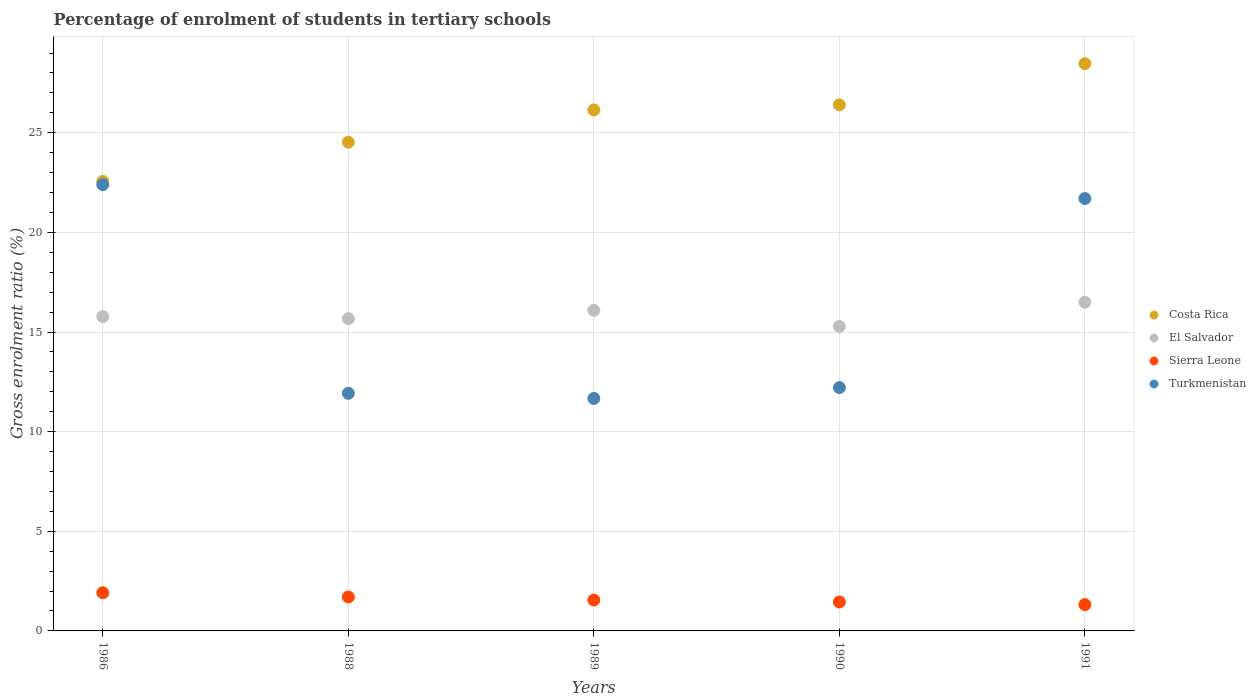What is the percentage of students enrolled in tertiary schools in Costa Rica in 1990?
Provide a succinct answer. 26.4. Across all years, what is the maximum percentage of students enrolled in tertiary schools in Turkmenistan?
Keep it short and to the point. 22.4. Across all years, what is the minimum percentage of students enrolled in tertiary schools in Costa Rica?
Provide a short and direct response. 22.56. What is the total percentage of students enrolled in tertiary schools in El Salvador in the graph?
Your answer should be compact. 79.31. What is the difference between the percentage of students enrolled in tertiary schools in Turkmenistan in 1986 and that in 1989?
Your answer should be very brief. 10.73. What is the difference between the percentage of students enrolled in tertiary schools in El Salvador in 1988 and the percentage of students enrolled in tertiary schools in Turkmenistan in 1989?
Your answer should be compact. 4.01. What is the average percentage of students enrolled in tertiary schools in Turkmenistan per year?
Offer a terse response. 15.98. In the year 1990, what is the difference between the percentage of students enrolled in tertiary schools in Costa Rica and percentage of students enrolled in tertiary schools in El Salvador?
Offer a very short reply. 11.12. What is the ratio of the percentage of students enrolled in tertiary schools in Turkmenistan in 1986 to that in 1991?
Offer a terse response. 1.03. Is the percentage of students enrolled in tertiary schools in Costa Rica in 1986 less than that in 1990?
Offer a very short reply. Yes. Is the difference between the percentage of students enrolled in tertiary schools in Costa Rica in 1988 and 1989 greater than the difference between the percentage of students enrolled in tertiary schools in El Salvador in 1988 and 1989?
Keep it short and to the point. No. What is the difference between the highest and the second highest percentage of students enrolled in tertiary schools in Costa Rica?
Your answer should be very brief. 2.07. What is the difference between the highest and the lowest percentage of students enrolled in tertiary schools in El Salvador?
Make the answer very short. 1.22. In how many years, is the percentage of students enrolled in tertiary schools in Sierra Leone greater than the average percentage of students enrolled in tertiary schools in Sierra Leone taken over all years?
Offer a terse response. 2. Is it the case that in every year, the sum of the percentage of students enrolled in tertiary schools in Sierra Leone and percentage of students enrolled in tertiary schools in El Salvador  is greater than the percentage of students enrolled in tertiary schools in Turkmenistan?
Offer a very short reply. No. Is the percentage of students enrolled in tertiary schools in Sierra Leone strictly less than the percentage of students enrolled in tertiary schools in Turkmenistan over the years?
Your response must be concise. Yes. How many dotlines are there?
Ensure brevity in your answer.  4. How many years are there in the graph?
Ensure brevity in your answer.  5. Are the values on the major ticks of Y-axis written in scientific E-notation?
Make the answer very short. No. Does the graph contain grids?
Make the answer very short. Yes. Where does the legend appear in the graph?
Offer a terse response. Center right. How many legend labels are there?
Ensure brevity in your answer.  4. How are the legend labels stacked?
Your answer should be very brief. Vertical. What is the title of the graph?
Make the answer very short. Percentage of enrolment of students in tertiary schools. What is the label or title of the X-axis?
Ensure brevity in your answer.  Years. What is the label or title of the Y-axis?
Your answer should be compact. Gross enrolment ratio (%). What is the Gross enrolment ratio (%) in Costa Rica in 1986?
Your answer should be very brief. 22.56. What is the Gross enrolment ratio (%) in El Salvador in 1986?
Give a very brief answer. 15.77. What is the Gross enrolment ratio (%) in Sierra Leone in 1986?
Make the answer very short. 1.92. What is the Gross enrolment ratio (%) of Turkmenistan in 1986?
Your answer should be compact. 22.4. What is the Gross enrolment ratio (%) of Costa Rica in 1988?
Keep it short and to the point. 24.52. What is the Gross enrolment ratio (%) in El Salvador in 1988?
Ensure brevity in your answer.  15.67. What is the Gross enrolment ratio (%) in Sierra Leone in 1988?
Offer a terse response. 1.7. What is the Gross enrolment ratio (%) of Turkmenistan in 1988?
Offer a terse response. 11.92. What is the Gross enrolment ratio (%) of Costa Rica in 1989?
Keep it short and to the point. 26.14. What is the Gross enrolment ratio (%) of El Salvador in 1989?
Make the answer very short. 16.09. What is the Gross enrolment ratio (%) of Sierra Leone in 1989?
Your response must be concise. 1.55. What is the Gross enrolment ratio (%) of Turkmenistan in 1989?
Offer a terse response. 11.66. What is the Gross enrolment ratio (%) of Costa Rica in 1990?
Make the answer very short. 26.4. What is the Gross enrolment ratio (%) of El Salvador in 1990?
Offer a terse response. 15.28. What is the Gross enrolment ratio (%) in Sierra Leone in 1990?
Your answer should be very brief. 1.45. What is the Gross enrolment ratio (%) in Turkmenistan in 1990?
Provide a short and direct response. 12.21. What is the Gross enrolment ratio (%) of Costa Rica in 1991?
Make the answer very short. 28.47. What is the Gross enrolment ratio (%) of El Salvador in 1991?
Provide a short and direct response. 16.49. What is the Gross enrolment ratio (%) in Sierra Leone in 1991?
Make the answer very short. 1.32. What is the Gross enrolment ratio (%) in Turkmenistan in 1991?
Provide a succinct answer. 21.7. Across all years, what is the maximum Gross enrolment ratio (%) in Costa Rica?
Offer a terse response. 28.47. Across all years, what is the maximum Gross enrolment ratio (%) in El Salvador?
Keep it short and to the point. 16.49. Across all years, what is the maximum Gross enrolment ratio (%) of Sierra Leone?
Provide a short and direct response. 1.92. Across all years, what is the maximum Gross enrolment ratio (%) in Turkmenistan?
Provide a succinct answer. 22.4. Across all years, what is the minimum Gross enrolment ratio (%) in Costa Rica?
Provide a short and direct response. 22.56. Across all years, what is the minimum Gross enrolment ratio (%) of El Salvador?
Provide a succinct answer. 15.28. Across all years, what is the minimum Gross enrolment ratio (%) in Sierra Leone?
Offer a very short reply. 1.32. Across all years, what is the minimum Gross enrolment ratio (%) of Turkmenistan?
Your response must be concise. 11.66. What is the total Gross enrolment ratio (%) in Costa Rica in the graph?
Offer a terse response. 128.09. What is the total Gross enrolment ratio (%) in El Salvador in the graph?
Your response must be concise. 79.31. What is the total Gross enrolment ratio (%) in Sierra Leone in the graph?
Offer a terse response. 7.94. What is the total Gross enrolment ratio (%) in Turkmenistan in the graph?
Your answer should be very brief. 79.89. What is the difference between the Gross enrolment ratio (%) of Costa Rica in 1986 and that in 1988?
Your answer should be compact. -1.96. What is the difference between the Gross enrolment ratio (%) of El Salvador in 1986 and that in 1988?
Keep it short and to the point. 0.1. What is the difference between the Gross enrolment ratio (%) in Sierra Leone in 1986 and that in 1988?
Your answer should be very brief. 0.21. What is the difference between the Gross enrolment ratio (%) of Turkmenistan in 1986 and that in 1988?
Your answer should be very brief. 10.47. What is the difference between the Gross enrolment ratio (%) in Costa Rica in 1986 and that in 1989?
Make the answer very short. -3.58. What is the difference between the Gross enrolment ratio (%) of El Salvador in 1986 and that in 1989?
Offer a terse response. -0.32. What is the difference between the Gross enrolment ratio (%) in Sierra Leone in 1986 and that in 1989?
Offer a very short reply. 0.37. What is the difference between the Gross enrolment ratio (%) in Turkmenistan in 1986 and that in 1989?
Give a very brief answer. 10.73. What is the difference between the Gross enrolment ratio (%) in Costa Rica in 1986 and that in 1990?
Make the answer very short. -3.84. What is the difference between the Gross enrolment ratio (%) of El Salvador in 1986 and that in 1990?
Provide a succinct answer. 0.49. What is the difference between the Gross enrolment ratio (%) in Sierra Leone in 1986 and that in 1990?
Offer a terse response. 0.46. What is the difference between the Gross enrolment ratio (%) of Turkmenistan in 1986 and that in 1990?
Ensure brevity in your answer.  10.19. What is the difference between the Gross enrolment ratio (%) of Costa Rica in 1986 and that in 1991?
Make the answer very short. -5.91. What is the difference between the Gross enrolment ratio (%) in El Salvador in 1986 and that in 1991?
Offer a very short reply. -0.72. What is the difference between the Gross enrolment ratio (%) of Sierra Leone in 1986 and that in 1991?
Your answer should be compact. 0.6. What is the difference between the Gross enrolment ratio (%) of Turkmenistan in 1986 and that in 1991?
Make the answer very short. 0.7. What is the difference between the Gross enrolment ratio (%) of Costa Rica in 1988 and that in 1989?
Keep it short and to the point. -1.62. What is the difference between the Gross enrolment ratio (%) in El Salvador in 1988 and that in 1989?
Offer a very short reply. -0.42. What is the difference between the Gross enrolment ratio (%) of Sierra Leone in 1988 and that in 1989?
Offer a terse response. 0.15. What is the difference between the Gross enrolment ratio (%) of Turkmenistan in 1988 and that in 1989?
Your response must be concise. 0.26. What is the difference between the Gross enrolment ratio (%) in Costa Rica in 1988 and that in 1990?
Ensure brevity in your answer.  -1.88. What is the difference between the Gross enrolment ratio (%) of El Salvador in 1988 and that in 1990?
Ensure brevity in your answer.  0.39. What is the difference between the Gross enrolment ratio (%) of Sierra Leone in 1988 and that in 1990?
Your answer should be very brief. 0.25. What is the difference between the Gross enrolment ratio (%) of Turkmenistan in 1988 and that in 1990?
Provide a succinct answer. -0.29. What is the difference between the Gross enrolment ratio (%) in Costa Rica in 1988 and that in 1991?
Provide a succinct answer. -3.94. What is the difference between the Gross enrolment ratio (%) of El Salvador in 1988 and that in 1991?
Offer a terse response. -0.82. What is the difference between the Gross enrolment ratio (%) of Sierra Leone in 1988 and that in 1991?
Give a very brief answer. 0.38. What is the difference between the Gross enrolment ratio (%) in Turkmenistan in 1988 and that in 1991?
Ensure brevity in your answer.  -9.77. What is the difference between the Gross enrolment ratio (%) of Costa Rica in 1989 and that in 1990?
Your response must be concise. -0.26. What is the difference between the Gross enrolment ratio (%) of El Salvador in 1989 and that in 1990?
Offer a very short reply. 0.81. What is the difference between the Gross enrolment ratio (%) in Sierra Leone in 1989 and that in 1990?
Your answer should be compact. 0.1. What is the difference between the Gross enrolment ratio (%) of Turkmenistan in 1989 and that in 1990?
Make the answer very short. -0.55. What is the difference between the Gross enrolment ratio (%) in Costa Rica in 1989 and that in 1991?
Your answer should be compact. -2.32. What is the difference between the Gross enrolment ratio (%) of El Salvador in 1989 and that in 1991?
Give a very brief answer. -0.4. What is the difference between the Gross enrolment ratio (%) of Sierra Leone in 1989 and that in 1991?
Ensure brevity in your answer.  0.23. What is the difference between the Gross enrolment ratio (%) of Turkmenistan in 1989 and that in 1991?
Provide a succinct answer. -10.03. What is the difference between the Gross enrolment ratio (%) of Costa Rica in 1990 and that in 1991?
Ensure brevity in your answer.  -2.07. What is the difference between the Gross enrolment ratio (%) in El Salvador in 1990 and that in 1991?
Give a very brief answer. -1.22. What is the difference between the Gross enrolment ratio (%) in Sierra Leone in 1990 and that in 1991?
Give a very brief answer. 0.13. What is the difference between the Gross enrolment ratio (%) of Turkmenistan in 1990 and that in 1991?
Offer a very short reply. -9.48. What is the difference between the Gross enrolment ratio (%) of Costa Rica in 1986 and the Gross enrolment ratio (%) of El Salvador in 1988?
Offer a very short reply. 6.89. What is the difference between the Gross enrolment ratio (%) of Costa Rica in 1986 and the Gross enrolment ratio (%) of Sierra Leone in 1988?
Ensure brevity in your answer.  20.85. What is the difference between the Gross enrolment ratio (%) of Costa Rica in 1986 and the Gross enrolment ratio (%) of Turkmenistan in 1988?
Give a very brief answer. 10.63. What is the difference between the Gross enrolment ratio (%) in El Salvador in 1986 and the Gross enrolment ratio (%) in Sierra Leone in 1988?
Give a very brief answer. 14.07. What is the difference between the Gross enrolment ratio (%) in El Salvador in 1986 and the Gross enrolment ratio (%) in Turkmenistan in 1988?
Keep it short and to the point. 3.85. What is the difference between the Gross enrolment ratio (%) of Sierra Leone in 1986 and the Gross enrolment ratio (%) of Turkmenistan in 1988?
Offer a very short reply. -10.01. What is the difference between the Gross enrolment ratio (%) of Costa Rica in 1986 and the Gross enrolment ratio (%) of El Salvador in 1989?
Offer a very short reply. 6.47. What is the difference between the Gross enrolment ratio (%) of Costa Rica in 1986 and the Gross enrolment ratio (%) of Sierra Leone in 1989?
Your answer should be compact. 21.01. What is the difference between the Gross enrolment ratio (%) in Costa Rica in 1986 and the Gross enrolment ratio (%) in Turkmenistan in 1989?
Provide a short and direct response. 10.89. What is the difference between the Gross enrolment ratio (%) in El Salvador in 1986 and the Gross enrolment ratio (%) in Sierra Leone in 1989?
Ensure brevity in your answer.  14.22. What is the difference between the Gross enrolment ratio (%) in El Salvador in 1986 and the Gross enrolment ratio (%) in Turkmenistan in 1989?
Ensure brevity in your answer.  4.11. What is the difference between the Gross enrolment ratio (%) in Sierra Leone in 1986 and the Gross enrolment ratio (%) in Turkmenistan in 1989?
Give a very brief answer. -9.75. What is the difference between the Gross enrolment ratio (%) in Costa Rica in 1986 and the Gross enrolment ratio (%) in El Salvador in 1990?
Provide a short and direct response. 7.28. What is the difference between the Gross enrolment ratio (%) of Costa Rica in 1986 and the Gross enrolment ratio (%) of Sierra Leone in 1990?
Give a very brief answer. 21.11. What is the difference between the Gross enrolment ratio (%) of Costa Rica in 1986 and the Gross enrolment ratio (%) of Turkmenistan in 1990?
Keep it short and to the point. 10.35. What is the difference between the Gross enrolment ratio (%) of El Salvador in 1986 and the Gross enrolment ratio (%) of Sierra Leone in 1990?
Offer a very short reply. 14.32. What is the difference between the Gross enrolment ratio (%) in El Salvador in 1986 and the Gross enrolment ratio (%) in Turkmenistan in 1990?
Your answer should be compact. 3.56. What is the difference between the Gross enrolment ratio (%) of Sierra Leone in 1986 and the Gross enrolment ratio (%) of Turkmenistan in 1990?
Keep it short and to the point. -10.3. What is the difference between the Gross enrolment ratio (%) in Costa Rica in 1986 and the Gross enrolment ratio (%) in El Salvador in 1991?
Provide a short and direct response. 6.06. What is the difference between the Gross enrolment ratio (%) of Costa Rica in 1986 and the Gross enrolment ratio (%) of Sierra Leone in 1991?
Your response must be concise. 21.24. What is the difference between the Gross enrolment ratio (%) in Costa Rica in 1986 and the Gross enrolment ratio (%) in Turkmenistan in 1991?
Give a very brief answer. 0.86. What is the difference between the Gross enrolment ratio (%) in El Salvador in 1986 and the Gross enrolment ratio (%) in Sierra Leone in 1991?
Keep it short and to the point. 14.45. What is the difference between the Gross enrolment ratio (%) of El Salvador in 1986 and the Gross enrolment ratio (%) of Turkmenistan in 1991?
Give a very brief answer. -5.93. What is the difference between the Gross enrolment ratio (%) of Sierra Leone in 1986 and the Gross enrolment ratio (%) of Turkmenistan in 1991?
Your answer should be compact. -19.78. What is the difference between the Gross enrolment ratio (%) of Costa Rica in 1988 and the Gross enrolment ratio (%) of El Salvador in 1989?
Offer a very short reply. 8.43. What is the difference between the Gross enrolment ratio (%) of Costa Rica in 1988 and the Gross enrolment ratio (%) of Sierra Leone in 1989?
Offer a terse response. 22.97. What is the difference between the Gross enrolment ratio (%) of Costa Rica in 1988 and the Gross enrolment ratio (%) of Turkmenistan in 1989?
Give a very brief answer. 12.86. What is the difference between the Gross enrolment ratio (%) in El Salvador in 1988 and the Gross enrolment ratio (%) in Sierra Leone in 1989?
Offer a terse response. 14.12. What is the difference between the Gross enrolment ratio (%) in El Salvador in 1988 and the Gross enrolment ratio (%) in Turkmenistan in 1989?
Offer a very short reply. 4.01. What is the difference between the Gross enrolment ratio (%) of Sierra Leone in 1988 and the Gross enrolment ratio (%) of Turkmenistan in 1989?
Keep it short and to the point. -9.96. What is the difference between the Gross enrolment ratio (%) of Costa Rica in 1988 and the Gross enrolment ratio (%) of El Salvador in 1990?
Give a very brief answer. 9.25. What is the difference between the Gross enrolment ratio (%) in Costa Rica in 1988 and the Gross enrolment ratio (%) in Sierra Leone in 1990?
Offer a terse response. 23.07. What is the difference between the Gross enrolment ratio (%) of Costa Rica in 1988 and the Gross enrolment ratio (%) of Turkmenistan in 1990?
Make the answer very short. 12.31. What is the difference between the Gross enrolment ratio (%) in El Salvador in 1988 and the Gross enrolment ratio (%) in Sierra Leone in 1990?
Keep it short and to the point. 14.22. What is the difference between the Gross enrolment ratio (%) in El Salvador in 1988 and the Gross enrolment ratio (%) in Turkmenistan in 1990?
Your answer should be compact. 3.46. What is the difference between the Gross enrolment ratio (%) of Sierra Leone in 1988 and the Gross enrolment ratio (%) of Turkmenistan in 1990?
Provide a short and direct response. -10.51. What is the difference between the Gross enrolment ratio (%) of Costa Rica in 1988 and the Gross enrolment ratio (%) of El Salvador in 1991?
Give a very brief answer. 8.03. What is the difference between the Gross enrolment ratio (%) in Costa Rica in 1988 and the Gross enrolment ratio (%) in Sierra Leone in 1991?
Your response must be concise. 23.2. What is the difference between the Gross enrolment ratio (%) of Costa Rica in 1988 and the Gross enrolment ratio (%) of Turkmenistan in 1991?
Give a very brief answer. 2.83. What is the difference between the Gross enrolment ratio (%) in El Salvador in 1988 and the Gross enrolment ratio (%) in Sierra Leone in 1991?
Make the answer very short. 14.35. What is the difference between the Gross enrolment ratio (%) of El Salvador in 1988 and the Gross enrolment ratio (%) of Turkmenistan in 1991?
Your answer should be very brief. -6.03. What is the difference between the Gross enrolment ratio (%) in Sierra Leone in 1988 and the Gross enrolment ratio (%) in Turkmenistan in 1991?
Offer a very short reply. -19.99. What is the difference between the Gross enrolment ratio (%) in Costa Rica in 1989 and the Gross enrolment ratio (%) in El Salvador in 1990?
Your answer should be compact. 10.86. What is the difference between the Gross enrolment ratio (%) of Costa Rica in 1989 and the Gross enrolment ratio (%) of Sierra Leone in 1990?
Give a very brief answer. 24.69. What is the difference between the Gross enrolment ratio (%) of Costa Rica in 1989 and the Gross enrolment ratio (%) of Turkmenistan in 1990?
Ensure brevity in your answer.  13.93. What is the difference between the Gross enrolment ratio (%) in El Salvador in 1989 and the Gross enrolment ratio (%) in Sierra Leone in 1990?
Provide a short and direct response. 14.64. What is the difference between the Gross enrolment ratio (%) of El Salvador in 1989 and the Gross enrolment ratio (%) of Turkmenistan in 1990?
Provide a short and direct response. 3.88. What is the difference between the Gross enrolment ratio (%) of Sierra Leone in 1989 and the Gross enrolment ratio (%) of Turkmenistan in 1990?
Provide a short and direct response. -10.66. What is the difference between the Gross enrolment ratio (%) in Costa Rica in 1989 and the Gross enrolment ratio (%) in El Salvador in 1991?
Your response must be concise. 9.65. What is the difference between the Gross enrolment ratio (%) of Costa Rica in 1989 and the Gross enrolment ratio (%) of Sierra Leone in 1991?
Provide a succinct answer. 24.82. What is the difference between the Gross enrolment ratio (%) in Costa Rica in 1989 and the Gross enrolment ratio (%) in Turkmenistan in 1991?
Make the answer very short. 4.45. What is the difference between the Gross enrolment ratio (%) of El Salvador in 1989 and the Gross enrolment ratio (%) of Sierra Leone in 1991?
Ensure brevity in your answer.  14.77. What is the difference between the Gross enrolment ratio (%) of El Salvador in 1989 and the Gross enrolment ratio (%) of Turkmenistan in 1991?
Offer a terse response. -5.6. What is the difference between the Gross enrolment ratio (%) in Sierra Leone in 1989 and the Gross enrolment ratio (%) in Turkmenistan in 1991?
Make the answer very short. -20.15. What is the difference between the Gross enrolment ratio (%) of Costa Rica in 1990 and the Gross enrolment ratio (%) of El Salvador in 1991?
Provide a succinct answer. 9.9. What is the difference between the Gross enrolment ratio (%) of Costa Rica in 1990 and the Gross enrolment ratio (%) of Sierra Leone in 1991?
Your answer should be compact. 25.08. What is the difference between the Gross enrolment ratio (%) in Costa Rica in 1990 and the Gross enrolment ratio (%) in Turkmenistan in 1991?
Your response must be concise. 4.7. What is the difference between the Gross enrolment ratio (%) of El Salvador in 1990 and the Gross enrolment ratio (%) of Sierra Leone in 1991?
Provide a succinct answer. 13.96. What is the difference between the Gross enrolment ratio (%) of El Salvador in 1990 and the Gross enrolment ratio (%) of Turkmenistan in 1991?
Give a very brief answer. -6.42. What is the difference between the Gross enrolment ratio (%) of Sierra Leone in 1990 and the Gross enrolment ratio (%) of Turkmenistan in 1991?
Offer a terse response. -20.24. What is the average Gross enrolment ratio (%) in Costa Rica per year?
Your answer should be compact. 25.62. What is the average Gross enrolment ratio (%) in El Salvador per year?
Make the answer very short. 15.86. What is the average Gross enrolment ratio (%) of Sierra Leone per year?
Provide a succinct answer. 1.59. What is the average Gross enrolment ratio (%) of Turkmenistan per year?
Offer a very short reply. 15.98. In the year 1986, what is the difference between the Gross enrolment ratio (%) of Costa Rica and Gross enrolment ratio (%) of El Salvador?
Ensure brevity in your answer.  6.79. In the year 1986, what is the difference between the Gross enrolment ratio (%) of Costa Rica and Gross enrolment ratio (%) of Sierra Leone?
Make the answer very short. 20.64. In the year 1986, what is the difference between the Gross enrolment ratio (%) in Costa Rica and Gross enrolment ratio (%) in Turkmenistan?
Your response must be concise. 0.16. In the year 1986, what is the difference between the Gross enrolment ratio (%) in El Salvador and Gross enrolment ratio (%) in Sierra Leone?
Your answer should be compact. 13.86. In the year 1986, what is the difference between the Gross enrolment ratio (%) in El Salvador and Gross enrolment ratio (%) in Turkmenistan?
Make the answer very short. -6.63. In the year 1986, what is the difference between the Gross enrolment ratio (%) in Sierra Leone and Gross enrolment ratio (%) in Turkmenistan?
Give a very brief answer. -20.48. In the year 1988, what is the difference between the Gross enrolment ratio (%) in Costa Rica and Gross enrolment ratio (%) in El Salvador?
Give a very brief answer. 8.85. In the year 1988, what is the difference between the Gross enrolment ratio (%) of Costa Rica and Gross enrolment ratio (%) of Sierra Leone?
Your answer should be very brief. 22.82. In the year 1988, what is the difference between the Gross enrolment ratio (%) in Costa Rica and Gross enrolment ratio (%) in Turkmenistan?
Make the answer very short. 12.6. In the year 1988, what is the difference between the Gross enrolment ratio (%) of El Salvador and Gross enrolment ratio (%) of Sierra Leone?
Your response must be concise. 13.97. In the year 1988, what is the difference between the Gross enrolment ratio (%) in El Salvador and Gross enrolment ratio (%) in Turkmenistan?
Make the answer very short. 3.75. In the year 1988, what is the difference between the Gross enrolment ratio (%) in Sierra Leone and Gross enrolment ratio (%) in Turkmenistan?
Your response must be concise. -10.22. In the year 1989, what is the difference between the Gross enrolment ratio (%) in Costa Rica and Gross enrolment ratio (%) in El Salvador?
Your response must be concise. 10.05. In the year 1989, what is the difference between the Gross enrolment ratio (%) in Costa Rica and Gross enrolment ratio (%) in Sierra Leone?
Give a very brief answer. 24.59. In the year 1989, what is the difference between the Gross enrolment ratio (%) of Costa Rica and Gross enrolment ratio (%) of Turkmenistan?
Make the answer very short. 14.48. In the year 1989, what is the difference between the Gross enrolment ratio (%) in El Salvador and Gross enrolment ratio (%) in Sierra Leone?
Provide a short and direct response. 14.54. In the year 1989, what is the difference between the Gross enrolment ratio (%) in El Salvador and Gross enrolment ratio (%) in Turkmenistan?
Your answer should be compact. 4.43. In the year 1989, what is the difference between the Gross enrolment ratio (%) in Sierra Leone and Gross enrolment ratio (%) in Turkmenistan?
Your answer should be compact. -10.12. In the year 1990, what is the difference between the Gross enrolment ratio (%) of Costa Rica and Gross enrolment ratio (%) of El Salvador?
Your answer should be compact. 11.12. In the year 1990, what is the difference between the Gross enrolment ratio (%) of Costa Rica and Gross enrolment ratio (%) of Sierra Leone?
Provide a short and direct response. 24.95. In the year 1990, what is the difference between the Gross enrolment ratio (%) of Costa Rica and Gross enrolment ratio (%) of Turkmenistan?
Give a very brief answer. 14.19. In the year 1990, what is the difference between the Gross enrolment ratio (%) of El Salvador and Gross enrolment ratio (%) of Sierra Leone?
Offer a terse response. 13.83. In the year 1990, what is the difference between the Gross enrolment ratio (%) of El Salvador and Gross enrolment ratio (%) of Turkmenistan?
Your response must be concise. 3.07. In the year 1990, what is the difference between the Gross enrolment ratio (%) of Sierra Leone and Gross enrolment ratio (%) of Turkmenistan?
Your answer should be compact. -10.76. In the year 1991, what is the difference between the Gross enrolment ratio (%) in Costa Rica and Gross enrolment ratio (%) in El Salvador?
Give a very brief answer. 11.97. In the year 1991, what is the difference between the Gross enrolment ratio (%) of Costa Rica and Gross enrolment ratio (%) of Sierra Leone?
Provide a short and direct response. 27.15. In the year 1991, what is the difference between the Gross enrolment ratio (%) of Costa Rica and Gross enrolment ratio (%) of Turkmenistan?
Keep it short and to the point. 6.77. In the year 1991, what is the difference between the Gross enrolment ratio (%) in El Salvador and Gross enrolment ratio (%) in Sierra Leone?
Provide a succinct answer. 15.17. In the year 1991, what is the difference between the Gross enrolment ratio (%) in El Salvador and Gross enrolment ratio (%) in Turkmenistan?
Provide a succinct answer. -5.2. In the year 1991, what is the difference between the Gross enrolment ratio (%) of Sierra Leone and Gross enrolment ratio (%) of Turkmenistan?
Offer a very short reply. -20.38. What is the ratio of the Gross enrolment ratio (%) of Costa Rica in 1986 to that in 1988?
Your answer should be very brief. 0.92. What is the ratio of the Gross enrolment ratio (%) in El Salvador in 1986 to that in 1988?
Ensure brevity in your answer.  1.01. What is the ratio of the Gross enrolment ratio (%) of Sierra Leone in 1986 to that in 1988?
Make the answer very short. 1.12. What is the ratio of the Gross enrolment ratio (%) in Turkmenistan in 1986 to that in 1988?
Ensure brevity in your answer.  1.88. What is the ratio of the Gross enrolment ratio (%) of Costa Rica in 1986 to that in 1989?
Keep it short and to the point. 0.86. What is the ratio of the Gross enrolment ratio (%) of El Salvador in 1986 to that in 1989?
Provide a succinct answer. 0.98. What is the ratio of the Gross enrolment ratio (%) in Sierra Leone in 1986 to that in 1989?
Provide a short and direct response. 1.24. What is the ratio of the Gross enrolment ratio (%) in Turkmenistan in 1986 to that in 1989?
Your response must be concise. 1.92. What is the ratio of the Gross enrolment ratio (%) of Costa Rica in 1986 to that in 1990?
Offer a terse response. 0.85. What is the ratio of the Gross enrolment ratio (%) in El Salvador in 1986 to that in 1990?
Offer a terse response. 1.03. What is the ratio of the Gross enrolment ratio (%) of Sierra Leone in 1986 to that in 1990?
Your response must be concise. 1.32. What is the ratio of the Gross enrolment ratio (%) in Turkmenistan in 1986 to that in 1990?
Provide a short and direct response. 1.83. What is the ratio of the Gross enrolment ratio (%) in Costa Rica in 1986 to that in 1991?
Your response must be concise. 0.79. What is the ratio of the Gross enrolment ratio (%) in El Salvador in 1986 to that in 1991?
Provide a succinct answer. 0.96. What is the ratio of the Gross enrolment ratio (%) of Sierra Leone in 1986 to that in 1991?
Make the answer very short. 1.45. What is the ratio of the Gross enrolment ratio (%) in Turkmenistan in 1986 to that in 1991?
Provide a short and direct response. 1.03. What is the ratio of the Gross enrolment ratio (%) of Costa Rica in 1988 to that in 1989?
Your response must be concise. 0.94. What is the ratio of the Gross enrolment ratio (%) in El Salvador in 1988 to that in 1989?
Your response must be concise. 0.97. What is the ratio of the Gross enrolment ratio (%) in Sierra Leone in 1988 to that in 1989?
Ensure brevity in your answer.  1.1. What is the ratio of the Gross enrolment ratio (%) of Turkmenistan in 1988 to that in 1989?
Give a very brief answer. 1.02. What is the ratio of the Gross enrolment ratio (%) in Costa Rica in 1988 to that in 1990?
Your answer should be very brief. 0.93. What is the ratio of the Gross enrolment ratio (%) in El Salvador in 1988 to that in 1990?
Your answer should be compact. 1.03. What is the ratio of the Gross enrolment ratio (%) of Sierra Leone in 1988 to that in 1990?
Your response must be concise. 1.17. What is the ratio of the Gross enrolment ratio (%) of Turkmenistan in 1988 to that in 1990?
Your answer should be very brief. 0.98. What is the ratio of the Gross enrolment ratio (%) of Costa Rica in 1988 to that in 1991?
Give a very brief answer. 0.86. What is the ratio of the Gross enrolment ratio (%) of El Salvador in 1988 to that in 1991?
Your answer should be very brief. 0.95. What is the ratio of the Gross enrolment ratio (%) in Sierra Leone in 1988 to that in 1991?
Make the answer very short. 1.29. What is the ratio of the Gross enrolment ratio (%) of Turkmenistan in 1988 to that in 1991?
Make the answer very short. 0.55. What is the ratio of the Gross enrolment ratio (%) of Costa Rica in 1989 to that in 1990?
Offer a very short reply. 0.99. What is the ratio of the Gross enrolment ratio (%) of El Salvador in 1989 to that in 1990?
Your answer should be compact. 1.05. What is the ratio of the Gross enrolment ratio (%) of Sierra Leone in 1989 to that in 1990?
Make the answer very short. 1.07. What is the ratio of the Gross enrolment ratio (%) in Turkmenistan in 1989 to that in 1990?
Keep it short and to the point. 0.96. What is the ratio of the Gross enrolment ratio (%) in Costa Rica in 1989 to that in 1991?
Make the answer very short. 0.92. What is the ratio of the Gross enrolment ratio (%) in El Salvador in 1989 to that in 1991?
Keep it short and to the point. 0.98. What is the ratio of the Gross enrolment ratio (%) of Sierra Leone in 1989 to that in 1991?
Provide a succinct answer. 1.17. What is the ratio of the Gross enrolment ratio (%) of Turkmenistan in 1989 to that in 1991?
Your response must be concise. 0.54. What is the ratio of the Gross enrolment ratio (%) in Costa Rica in 1990 to that in 1991?
Make the answer very short. 0.93. What is the ratio of the Gross enrolment ratio (%) of El Salvador in 1990 to that in 1991?
Offer a terse response. 0.93. What is the ratio of the Gross enrolment ratio (%) of Sierra Leone in 1990 to that in 1991?
Ensure brevity in your answer.  1.1. What is the ratio of the Gross enrolment ratio (%) of Turkmenistan in 1990 to that in 1991?
Provide a short and direct response. 0.56. What is the difference between the highest and the second highest Gross enrolment ratio (%) in Costa Rica?
Give a very brief answer. 2.07. What is the difference between the highest and the second highest Gross enrolment ratio (%) of El Salvador?
Make the answer very short. 0.4. What is the difference between the highest and the second highest Gross enrolment ratio (%) of Sierra Leone?
Offer a terse response. 0.21. What is the difference between the highest and the second highest Gross enrolment ratio (%) in Turkmenistan?
Your answer should be very brief. 0.7. What is the difference between the highest and the lowest Gross enrolment ratio (%) in Costa Rica?
Provide a succinct answer. 5.91. What is the difference between the highest and the lowest Gross enrolment ratio (%) of El Salvador?
Your response must be concise. 1.22. What is the difference between the highest and the lowest Gross enrolment ratio (%) of Sierra Leone?
Ensure brevity in your answer.  0.6. What is the difference between the highest and the lowest Gross enrolment ratio (%) in Turkmenistan?
Your answer should be very brief. 10.73. 